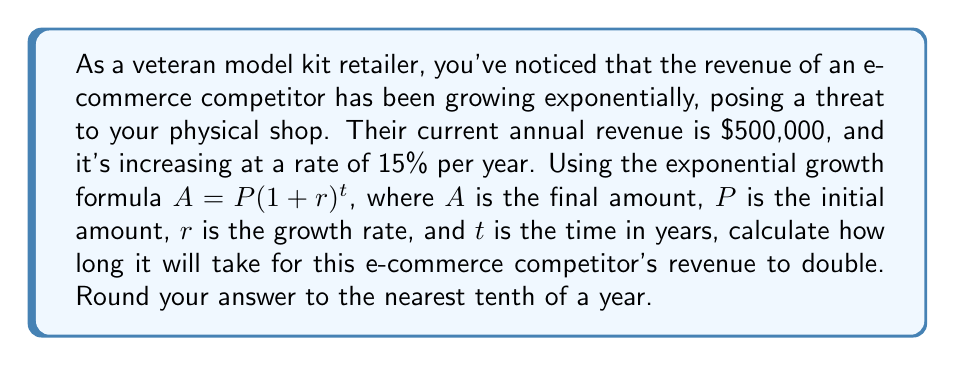Show me your answer to this math problem. To solve this problem, we'll use the exponential growth formula and the concept of doubling time:

1) The exponential growth formula is:
   $A = P(1 + r)^t$

2) We know that:
   $P = 500,000$ (initial revenue)
   $r = 0.15$ (15% growth rate)
   $A = 2P = 1,000,000$ (double the initial revenue)

3) Substituting these values into the formula:
   $1,000,000 = 500,000(1 + 0.15)^t$

4) Simplify:
   $2 = (1.15)^t$

5) Take the natural logarithm of both sides:
   $\ln(2) = t \cdot \ln(1.15)$

6) Solve for $t$:
   $t = \frac{\ln(2)}{\ln(1.15)}$

7) Calculate:
   $t \approx 4.9593$ years

8) Rounding to the nearest tenth:
   $t \approx 5.0$ years
Answer: It will take approximately 5.0 years for the e-commerce competitor's revenue to double. 